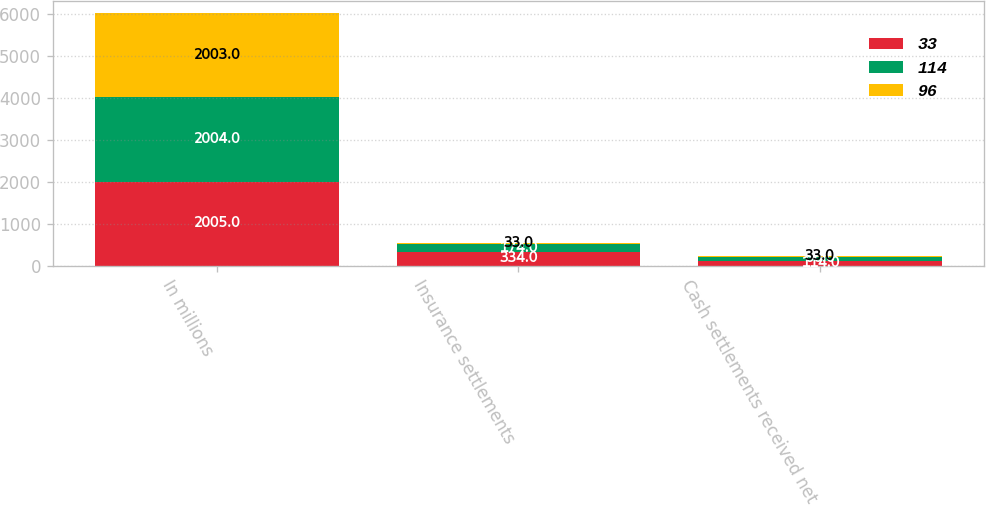Convert chart. <chart><loc_0><loc_0><loc_500><loc_500><stacked_bar_chart><ecel><fcel>In millions<fcel>Insurance settlements<fcel>Cash settlements received net<nl><fcel>33<fcel>2005<fcel>334<fcel>114<nl><fcel>114<fcel>2004<fcel>174<fcel>96<nl><fcel>96<fcel>2003<fcel>33<fcel>33<nl></chart> 